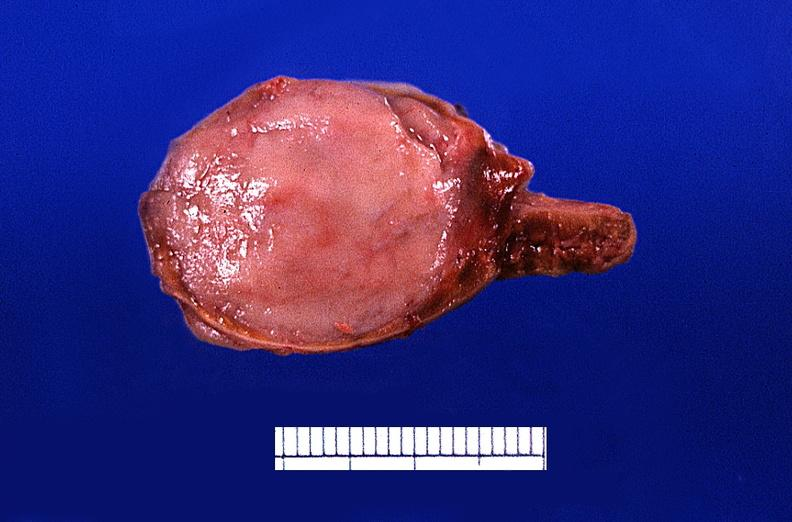does this image show adrenal medullary tumor?
Answer the question using a single word or phrase. Yes 